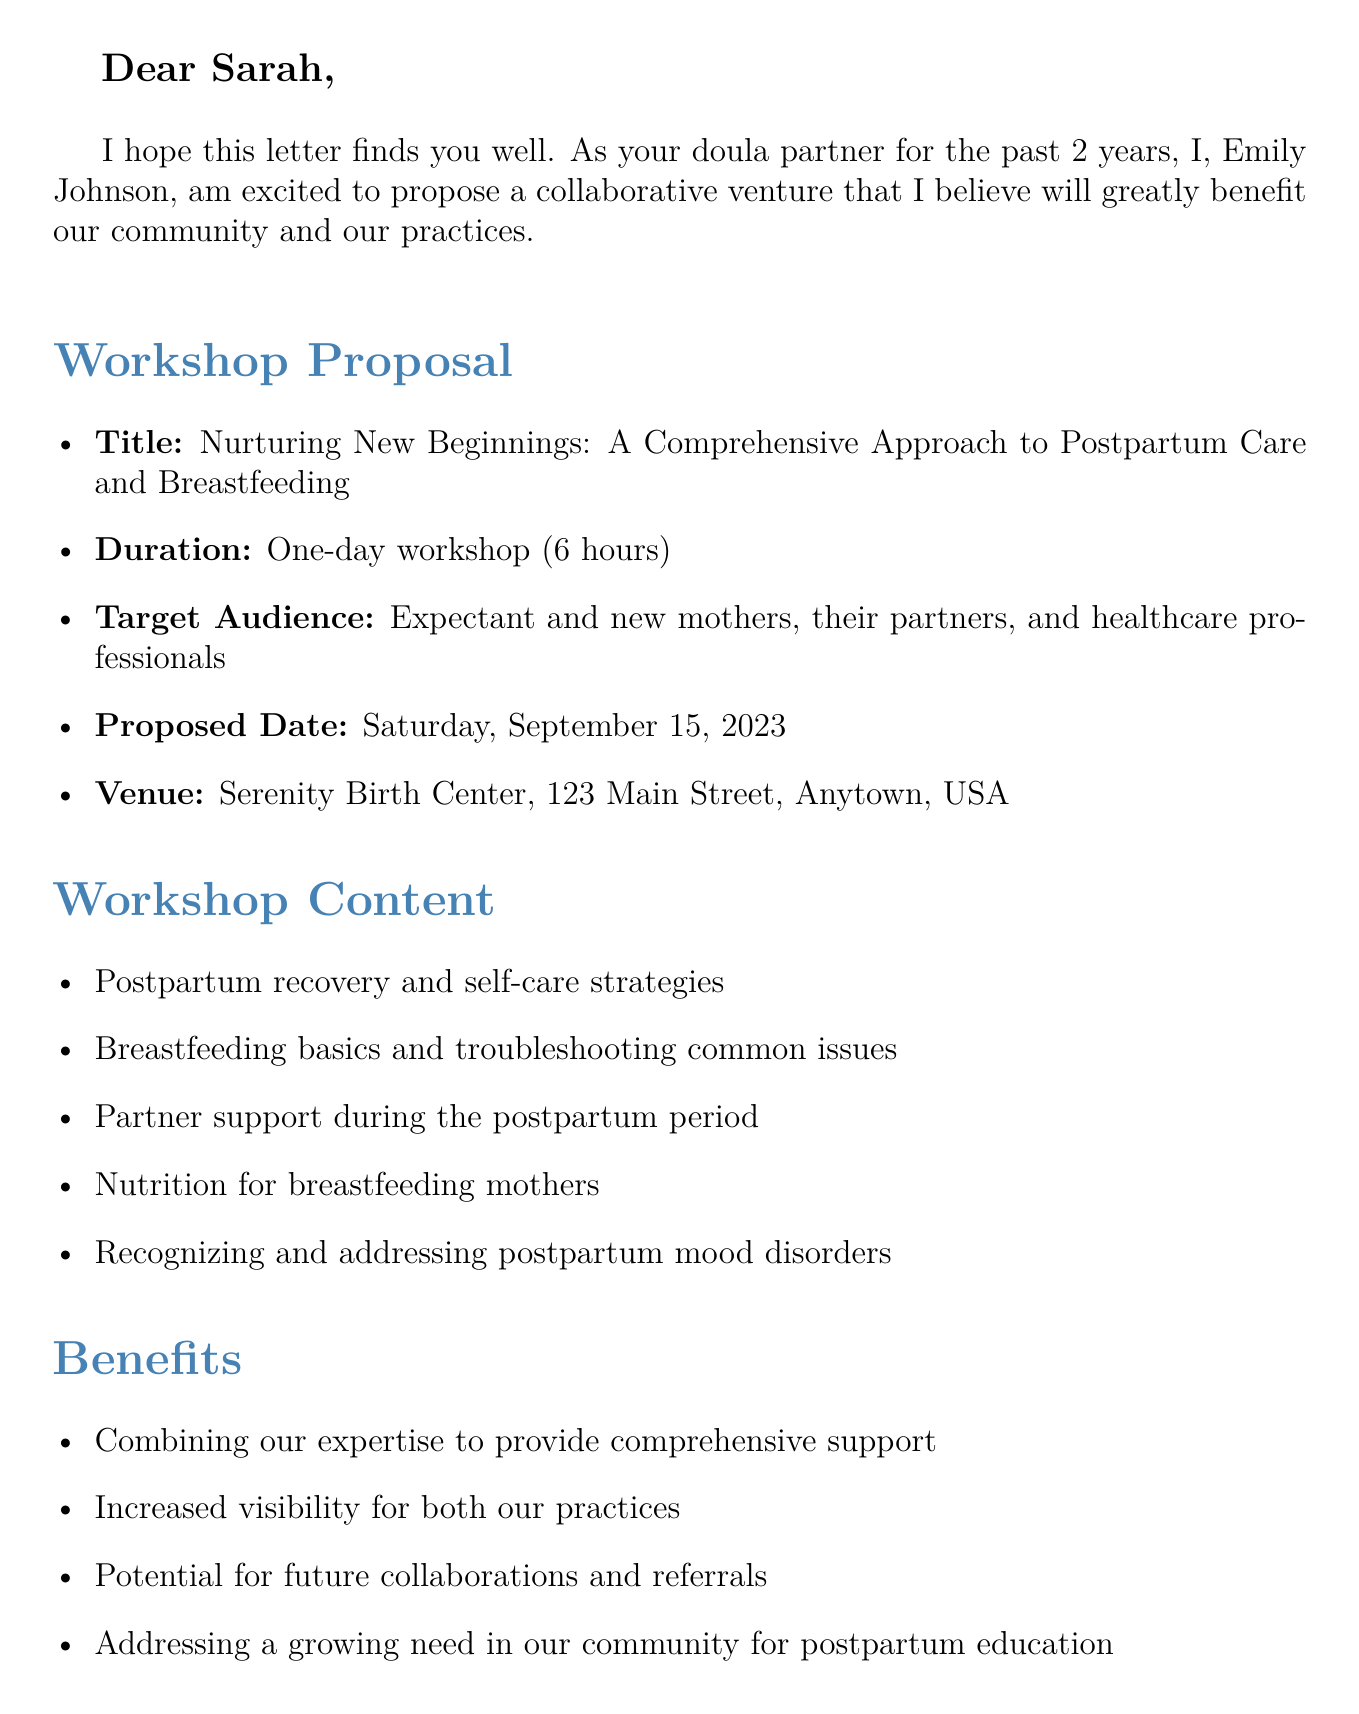What is the title of the workshop? The title of the workshop is explicitly mentioned in the document under the workshop proposal section.
Answer: Nurturing New Beginnings: A Comprehensive Approach to Postpartum Care and Breastfeeding Who is proposing the workshop? The sender's name is mentioned in the greeting and introduction, indicating who is making the proposal.
Answer: Emily Johnson What is the proposed date of the workshop? The date is specified in the workshop proposal section of the document.
Answer: Saturday, September 15, 2023 How long is the workshop? The duration of the workshop is detailed in the workshop proposal section.
Answer: One-day workshop (6 hours) What is the maximum number of participants allowed? This number is provided in the logistics section of the document.
Answer: 20 What are the benefits of the workshop stated in the document? Benefits are listed as bullets in the benefits section; the response summarizes this information.
Answer: Combining our expertise to provide comprehensive support What is the proposed fee per participant? The fee is clearly stated in the logistics section of the proposal.
Answer: $150 per participant What is the revenue split after expenses? This detail is explicitly included in the logistics section of the document.
Answer: 50/50 after expenses When does Emily suggest discussing the proposal further? This information is indicated in the call to action section towards the end of the document.
Answer: Next week 